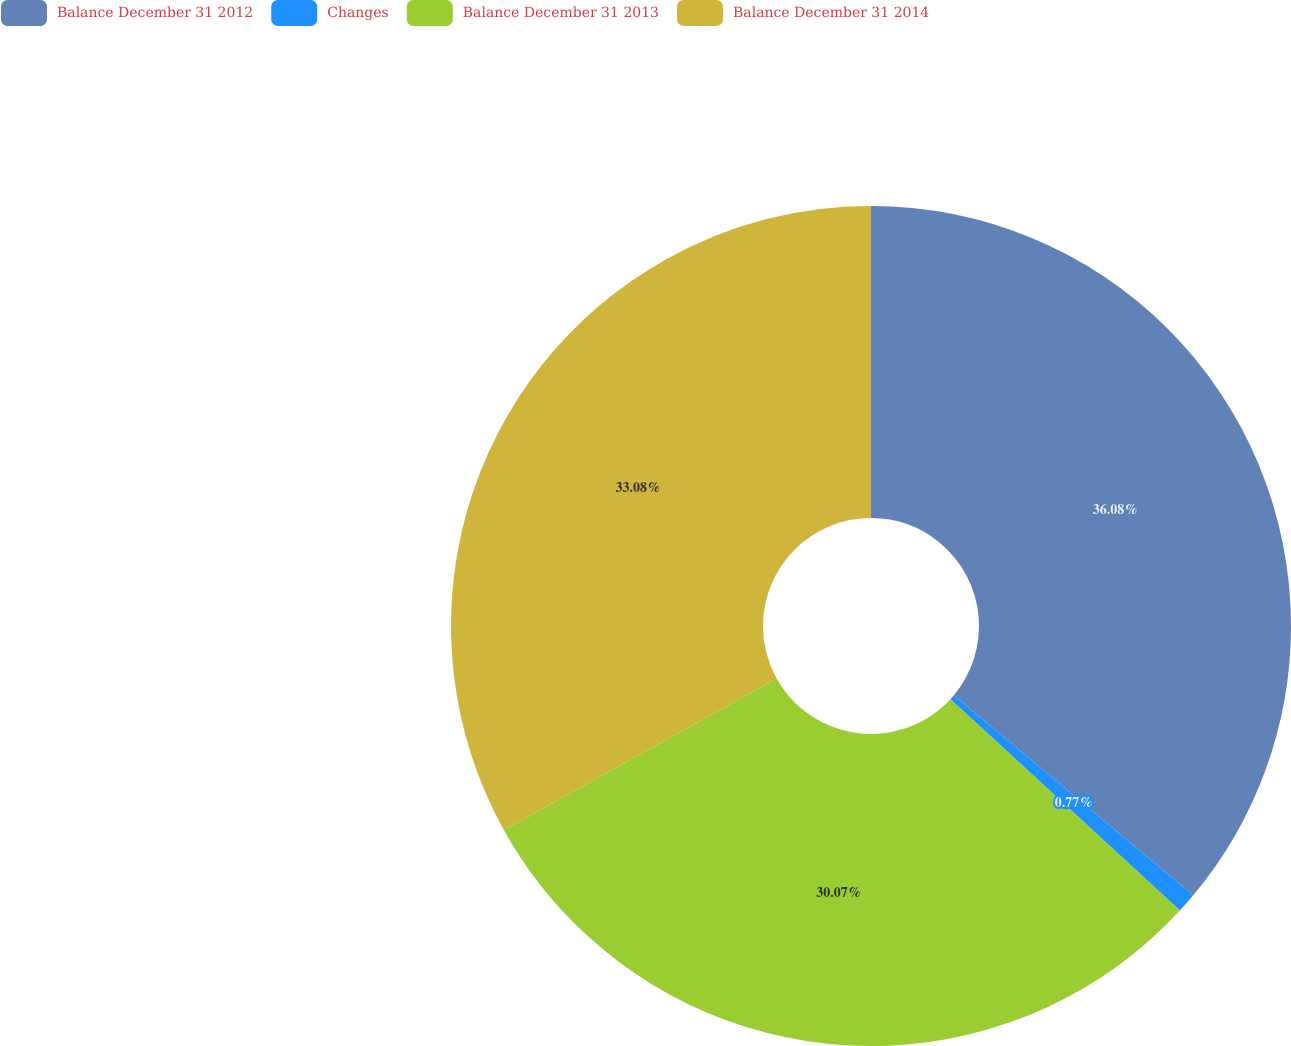Convert chart. <chart><loc_0><loc_0><loc_500><loc_500><pie_chart><fcel>Balance December 31 2012<fcel>Changes<fcel>Balance December 31 2013<fcel>Balance December 31 2014<nl><fcel>36.08%<fcel>0.77%<fcel>30.07%<fcel>33.08%<nl></chart> 